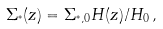<formula> <loc_0><loc_0><loc_500><loc_500>\Sigma _ { ^ { * } } ( z ) = \Sigma _ { ^ { * } , 0 } H ( z ) / H _ { 0 } \, ,</formula> 